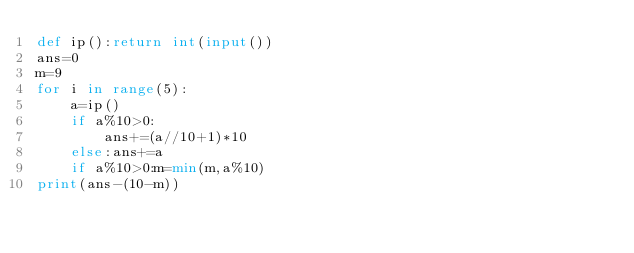Convert code to text. <code><loc_0><loc_0><loc_500><loc_500><_Python_>def ip():return int(input())
ans=0
m=9
for i in range(5):
    a=ip()
    if a%10>0:
        ans+=(a//10+1)*10
    else:ans+=a
    if a%10>0:m=min(m,a%10)
print(ans-(10-m))
</code> 